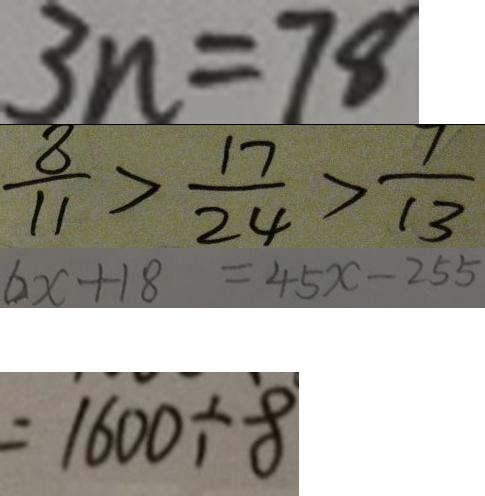Convert formula to latex. <formula><loc_0><loc_0><loc_500><loc_500>3 n = 7 8 
 \frac { 8 } { 1 1 } > \frac { 1 7 } { 2 4 } > \frac { 7 } { 1 3 } 
 6 x + 1 8 = 4 5 x - 2 5 5 
 = 1 6 0 0 \div 8</formula> 